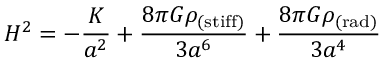<formula> <loc_0><loc_0><loc_500><loc_500>H ^ { 2 } = - \frac { K } { a ^ { 2 } } + \frac { 8 \pi G \rho _ { ( s t i f f ) } } { 3 a ^ { 6 } } + \frac { 8 \pi G \rho _ { ( r a d ) } } { 3 a ^ { 4 } }</formula> 